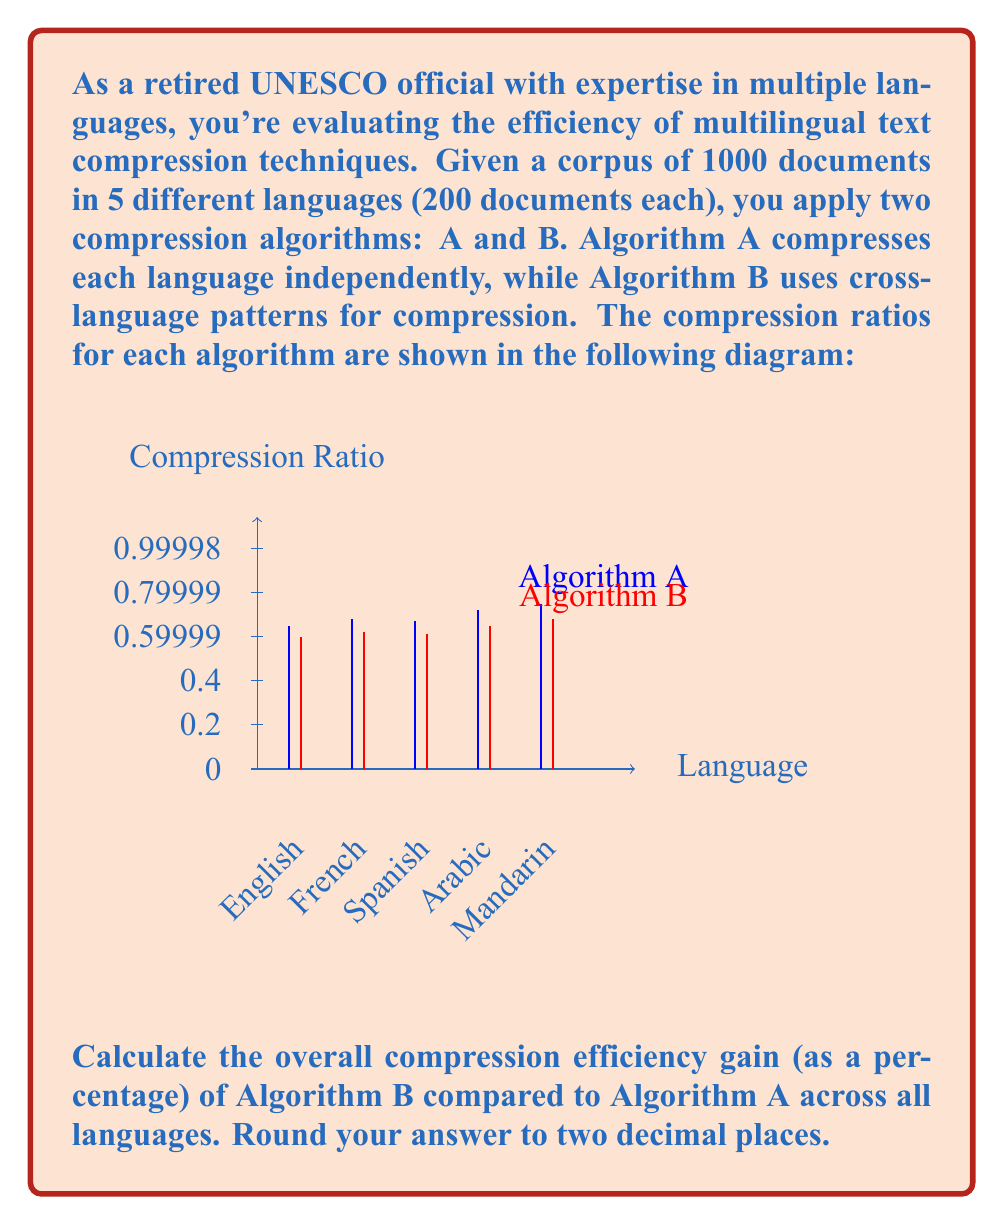Can you answer this question? To solve this problem, we'll follow these steps:

1) Calculate the average compression ratio for each algorithm:

   For Algorithm A:
   $$\text{Avg}_A = \frac{0.65 + 0.68 + 0.67 + 0.72 + 0.75}{5} = 0.694$$

   For Algorithm B:
   $$\text{Avg}_B = \frac{0.60 + 0.62 + 0.61 + 0.65 + 0.68}{5} = 0.632$$

2) Calculate the efficiency gain:
   The efficiency gain is the percentage decrease in the compression ratio.
   
   $$\text{Efficiency Gain} = \frac{\text{Avg}_A - \text{Avg}_B}{\text{Avg}_A} \times 100\%$$

3) Plug in the values:

   $$\text{Efficiency Gain} = \frac{0.694 - 0.632}{0.694} \times 100\%$$

4) Solve:

   $$\text{Efficiency Gain} = 0.0893 \times 100\% = 8.93\%$$

5) Round to two decimal places:

   $$\text{Efficiency Gain} \approx 8.93\%$$
Answer: 8.93% 